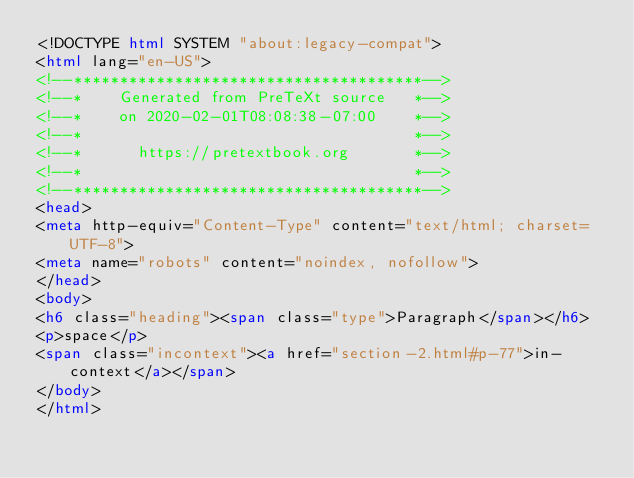Convert code to text. <code><loc_0><loc_0><loc_500><loc_500><_HTML_><!DOCTYPE html SYSTEM "about:legacy-compat">
<html lang="en-US">
<!--**************************************-->
<!--*    Generated from PreTeXt source   *-->
<!--*    on 2020-02-01T08:08:38-07:00    *-->
<!--*                                    *-->
<!--*      https://pretextbook.org       *-->
<!--*                                    *-->
<!--**************************************-->
<head>
<meta http-equiv="Content-Type" content="text/html; charset=UTF-8">
<meta name="robots" content="noindex, nofollow">
</head>
<body>
<h6 class="heading"><span class="type">Paragraph</span></h6>
<p>space</p>
<span class="incontext"><a href="section-2.html#p-77">in-context</a></span>
</body>
</html>
</code> 